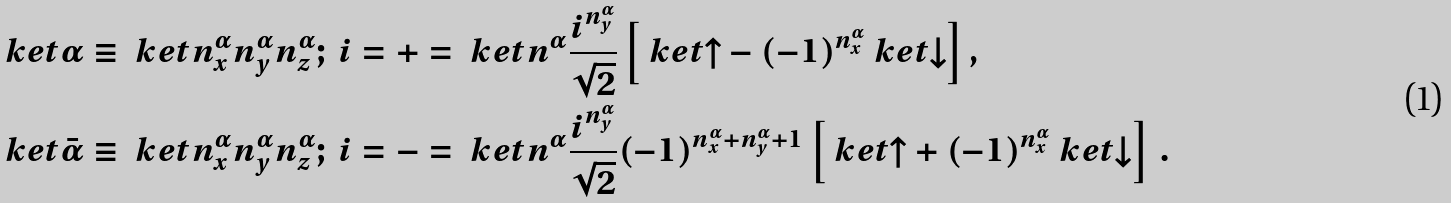<formula> <loc_0><loc_0><loc_500><loc_500>\ k e t { \alpha } \equiv \ k e t { n _ { x } ^ { \alpha } n _ { y } ^ { \alpha } n _ { z } ^ { \alpha } ; \, i = + } & = \ k e t { n ^ { \alpha } } \frac { i ^ { n _ { y } ^ { \alpha } } } { \sqrt { 2 } } \left [ \ k e t { \uparrow } - ( - 1 ) ^ { n _ { x } ^ { \alpha } } \ k e t { \downarrow } \right ] , \\ \ k e t { \bar { \alpha } } \equiv \ k e t { n _ { x } ^ { \alpha } n _ { y } ^ { \alpha } n _ { z } ^ { \alpha } ; \, i = - } & = \ k e t { n ^ { \alpha } } \frac { i ^ { n _ { y } ^ { \alpha } } } { \sqrt { 2 } } ( - 1 ) ^ { n _ { x } ^ { \alpha } + n _ { y } ^ { \alpha } + 1 } \left [ \ k e t { \uparrow } + ( - 1 ) ^ { n _ { x } ^ { \alpha } } \ k e t { \downarrow } \right ] \, .</formula> 